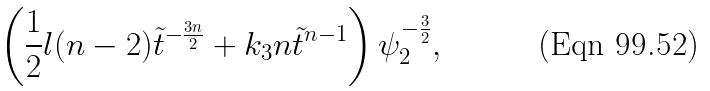<formula> <loc_0><loc_0><loc_500><loc_500>\left ( \frac { 1 } { 2 } l ( n - 2 ) { \tilde { t } } ^ { - \frac { 3 n } { 2 } } + k _ { 3 } n \tilde { t } ^ { n - 1 } \right ) \psi _ { 2 } ^ { - \frac { 3 } { 2 } } ,</formula> 